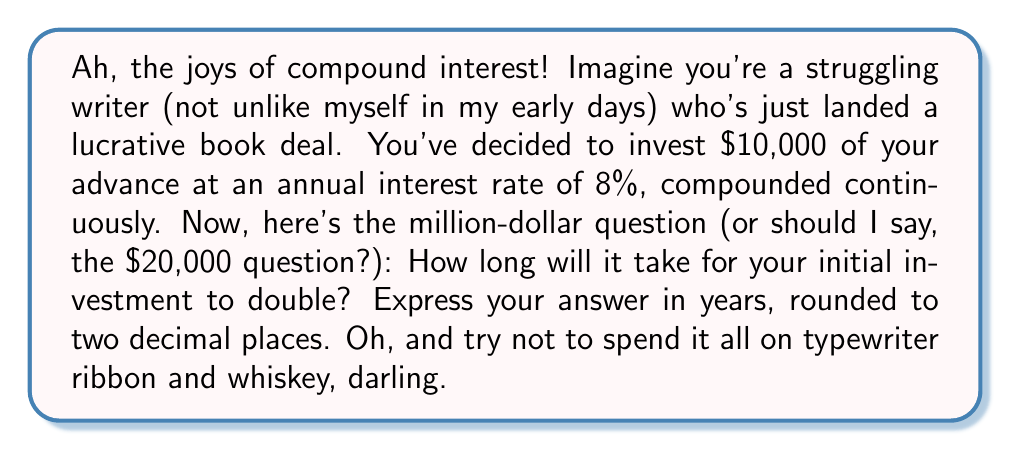Can you answer this question? Well, well, well, let's unravel this financial mystery, shall we? Pour yourself a strong cup of coffee (or something stronger, I won't judge) and let's dive in.

1) First, we need to recall the formula for continuous compound interest:
   $$A = P e^{rt}$$
   Where:
   $A$ is the final amount
   $P$ is the principal (initial investment)
   $e$ is Euler's number (approximately 2.71828)
   $r$ is the annual interest rate (as a decimal)
   $t$ is the time in years

2) We want to know when the amount has doubled, so:
   $$2P = P e^{rt}$$

3) Divide both sides by $P$ (assuming you haven't spent it all already):
   $$2 = e^{rt}$$

4) Now, let's take the natural logarithm of both sides:
   $$\ln(2) = \ln(e^{rt})$$

5) The logarithm and exponent cancel on the right side:
   $$\ln(2) = rt$$

6) Solve for $t$ by dividing both sides by $r$:
   $$t = \frac{\ln(2)}{r}$$

7) Now, let's plug in our values:
   $r = 0.08$ (8% expressed as a decimal)
   
   $$t = \frac{\ln(2)}{0.08}$$

8) Use a calculator (or your superhuman math skills) to evaluate:
   $$t \approx 8.6643$$

9) Rounding to two decimal places:
   $$t \approx 8.66\text{ years}$$

And there you have it! Your money will double faster than your writer's block disappears.
Answer: $8.66\text{ years}$ 